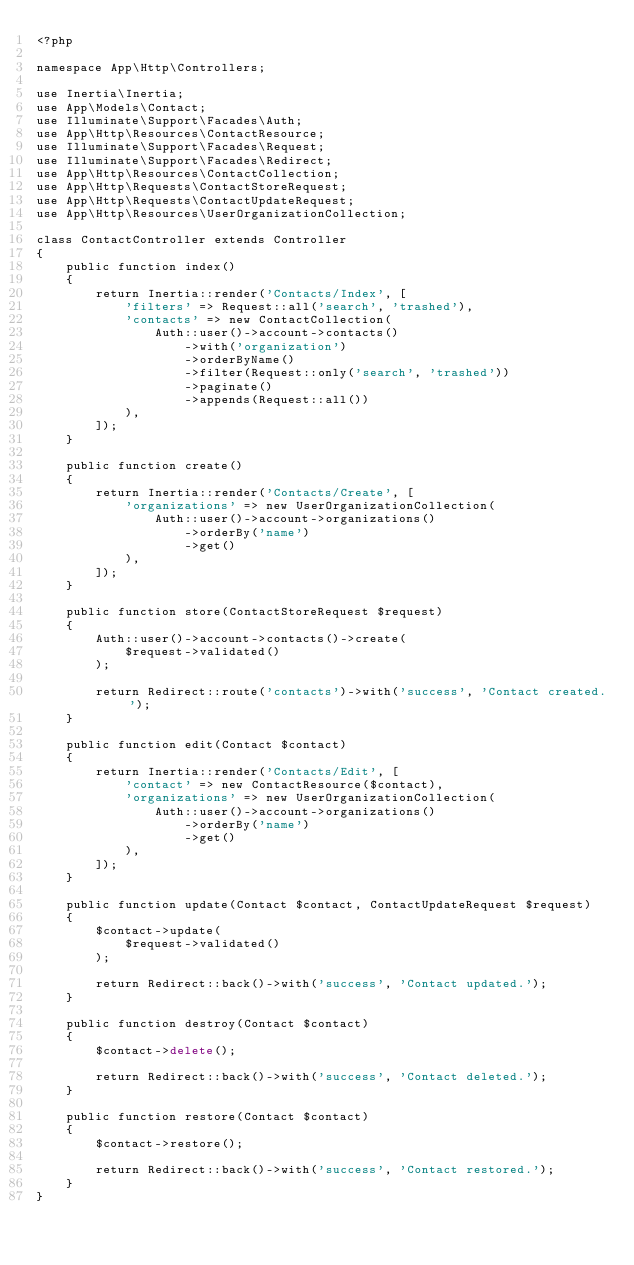Convert code to text. <code><loc_0><loc_0><loc_500><loc_500><_PHP_><?php

namespace App\Http\Controllers;

use Inertia\Inertia;
use App\Models\Contact;
use Illuminate\Support\Facades\Auth;
use App\Http\Resources\ContactResource;
use Illuminate\Support\Facades\Request;
use Illuminate\Support\Facades\Redirect;
use App\Http\Resources\ContactCollection;
use App\Http\Requests\ContactStoreRequest;
use App\Http\Requests\ContactUpdateRequest;
use App\Http\Resources\UserOrganizationCollection;

class ContactController extends Controller
{
    public function index()
    {
        return Inertia::render('Contacts/Index', [
            'filters' => Request::all('search', 'trashed'),
            'contacts' => new ContactCollection(
                Auth::user()->account->contacts()
                    ->with('organization')
                    ->orderByName()
                    ->filter(Request::only('search', 'trashed'))
                    ->paginate()
                    ->appends(Request::all())
            ),
        ]);
    }

    public function create()
    {
        return Inertia::render('Contacts/Create', [
            'organizations' => new UserOrganizationCollection(
                Auth::user()->account->organizations()
                    ->orderBy('name')
                    ->get()
            ),
        ]);
    }

    public function store(ContactStoreRequest $request)
    {
        Auth::user()->account->contacts()->create(
            $request->validated()
        );

        return Redirect::route('contacts')->with('success', 'Contact created.');
    }

    public function edit(Contact $contact)
    {
        return Inertia::render('Contacts/Edit', [
            'contact' => new ContactResource($contact),
            'organizations' => new UserOrganizationCollection(
                Auth::user()->account->organizations()
                    ->orderBy('name')
                    ->get()
            ),
        ]);
    }

    public function update(Contact $contact, ContactUpdateRequest $request)
    {
        $contact->update(
            $request->validated()
        );

        return Redirect::back()->with('success', 'Contact updated.');
    }

    public function destroy(Contact $contact)
    {
        $contact->delete();

        return Redirect::back()->with('success', 'Contact deleted.');
    }

    public function restore(Contact $contact)
    {
        $contact->restore();

        return Redirect::back()->with('success', 'Contact restored.');
    }
}
</code> 